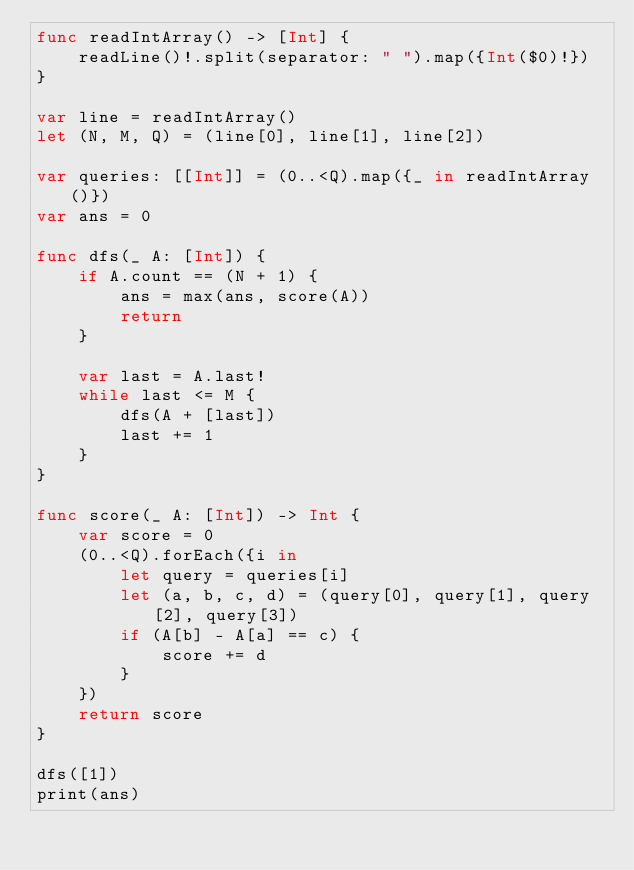Convert code to text. <code><loc_0><loc_0><loc_500><loc_500><_Swift_>func readIntArray() -> [Int] {
    readLine()!.split(separator: " ").map({Int($0)!})
}

var line = readIntArray()
let (N, M, Q) = (line[0], line[1], line[2])

var queries: [[Int]] = (0..<Q).map({_ in readIntArray()})
var ans = 0

func dfs(_ A: [Int]) {
    if A.count == (N + 1) {
        ans = max(ans, score(A))
        return
    }
    
    var last = A.last!
    while last <= M {
        dfs(A + [last])
        last += 1
    }
}

func score(_ A: [Int]) -> Int {
    var score = 0
    (0..<Q).forEach({i in
        let query = queries[i]
        let (a, b, c, d) = (query[0], query[1], query[2], query[3])
        if (A[b] - A[a] == c) {
            score += d
        }
    })
    return score
}

dfs([1])
print(ans)
</code> 